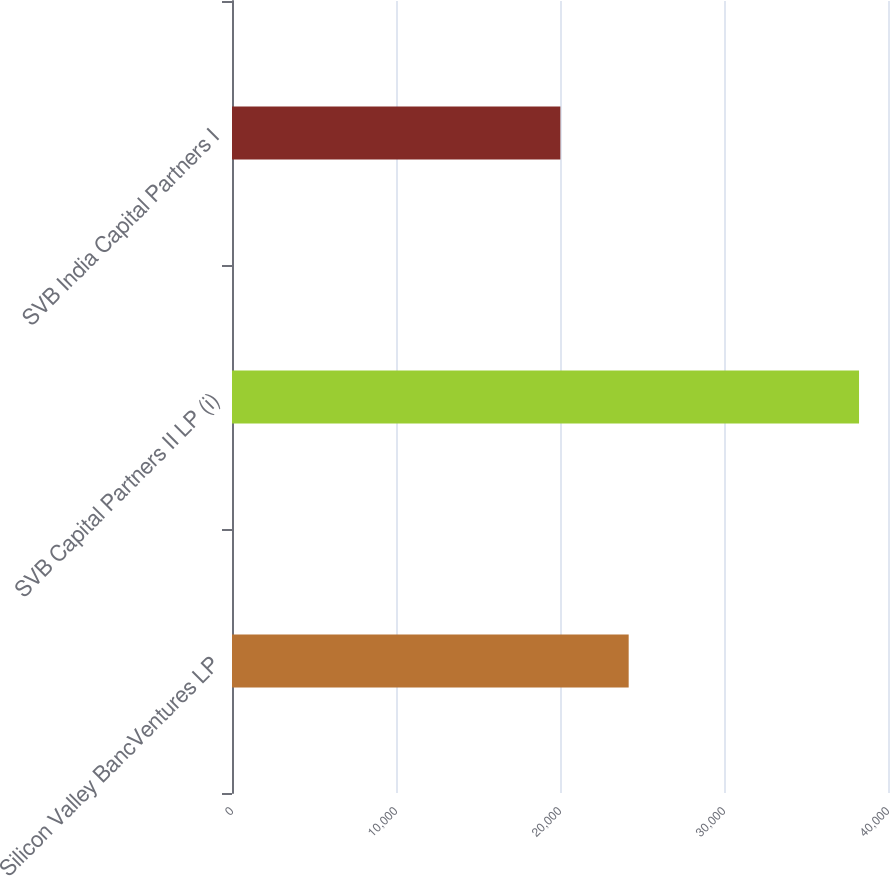<chart> <loc_0><loc_0><loc_500><loc_500><bar_chart><fcel>Silicon Valley BancVentures LP<fcel>SVB Capital Partners II LP (i)<fcel>SVB India Capital Partners I<nl><fcel>24188<fcel>38234<fcel>20022<nl></chart> 